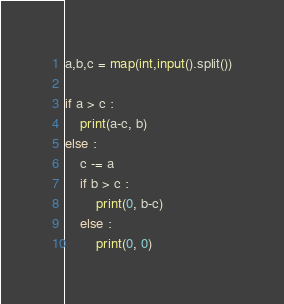<code> <loc_0><loc_0><loc_500><loc_500><_Python_>a,b,c = map(int,input().split())

if a > c :
    print(a-c, b)
else :
    c -= a
    if b > c :
        print(0, b-c)
    else :
        print(0, 0)
</code> 